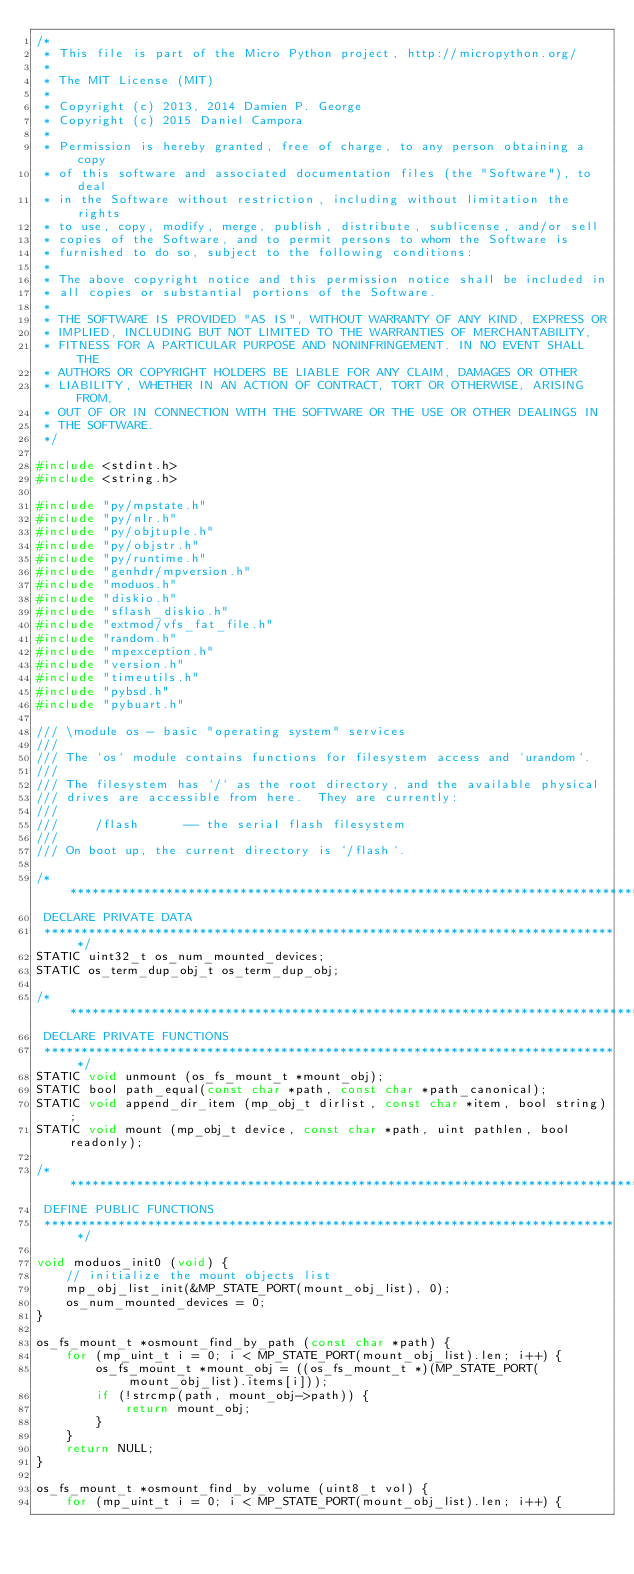<code> <loc_0><loc_0><loc_500><loc_500><_C_>/*
 * This file is part of the Micro Python project, http://micropython.org/
 *
 * The MIT License (MIT)
 *
 * Copyright (c) 2013, 2014 Damien P. George
 * Copyright (c) 2015 Daniel Campora
 *
 * Permission is hereby granted, free of charge, to any person obtaining a copy
 * of this software and associated documentation files (the "Software"), to deal
 * in the Software without restriction, including without limitation the rights
 * to use, copy, modify, merge, publish, distribute, sublicense, and/or sell
 * copies of the Software, and to permit persons to whom the Software is
 * furnished to do so, subject to the following conditions:
 *
 * The above copyright notice and this permission notice shall be included in
 * all copies or substantial portions of the Software.
 *
 * THE SOFTWARE IS PROVIDED "AS IS", WITHOUT WARRANTY OF ANY KIND, EXPRESS OR
 * IMPLIED, INCLUDING BUT NOT LIMITED TO THE WARRANTIES OF MERCHANTABILITY,
 * FITNESS FOR A PARTICULAR PURPOSE AND NONINFRINGEMENT. IN NO EVENT SHALL THE
 * AUTHORS OR COPYRIGHT HOLDERS BE LIABLE FOR ANY CLAIM, DAMAGES OR OTHER
 * LIABILITY, WHETHER IN AN ACTION OF CONTRACT, TORT OR OTHERWISE, ARISING FROM,
 * OUT OF OR IN CONNECTION WITH THE SOFTWARE OR THE USE OR OTHER DEALINGS IN
 * THE SOFTWARE.
 */

#include <stdint.h>
#include <string.h>

#include "py/mpstate.h"
#include "py/nlr.h"
#include "py/objtuple.h"
#include "py/objstr.h"
#include "py/runtime.h"
#include "genhdr/mpversion.h"
#include "moduos.h"
#include "diskio.h"
#include "sflash_diskio.h"
#include "extmod/vfs_fat_file.h"
#include "random.h"
#include "mpexception.h"
#include "version.h"
#include "timeutils.h"
#include "pybsd.h"
#include "pybuart.h"

/// \module os - basic "operating system" services
///
/// The `os` module contains functions for filesystem access and `urandom`.
///
/// The filesystem has `/` as the root directory, and the available physical
/// drives are accessible from here.  They are currently:
///
///     /flash      -- the serial flash filesystem
///
/// On boot up, the current directory is `/flash`.

/******************************************************************************
 DECLARE PRIVATE DATA
 ******************************************************************************/
STATIC uint32_t os_num_mounted_devices;
STATIC os_term_dup_obj_t os_term_dup_obj;

/******************************************************************************
 DECLARE PRIVATE FUNCTIONS
 ******************************************************************************/
STATIC void unmount (os_fs_mount_t *mount_obj);
STATIC bool path_equal(const char *path, const char *path_canonical);
STATIC void append_dir_item (mp_obj_t dirlist, const char *item, bool string);
STATIC void mount (mp_obj_t device, const char *path, uint pathlen, bool readonly);

/******************************************************************************
 DEFINE PUBLIC FUNCTIONS
 ******************************************************************************/

void moduos_init0 (void) {
    // initialize the mount objects list
    mp_obj_list_init(&MP_STATE_PORT(mount_obj_list), 0);
    os_num_mounted_devices = 0;
}

os_fs_mount_t *osmount_find_by_path (const char *path) {
    for (mp_uint_t i = 0; i < MP_STATE_PORT(mount_obj_list).len; i++) {
        os_fs_mount_t *mount_obj = ((os_fs_mount_t *)(MP_STATE_PORT(mount_obj_list).items[i]));
        if (!strcmp(path, mount_obj->path)) {
            return mount_obj;
        }
    }
    return NULL;
}

os_fs_mount_t *osmount_find_by_volume (uint8_t vol) {
    for (mp_uint_t i = 0; i < MP_STATE_PORT(mount_obj_list).len; i++) {</code> 